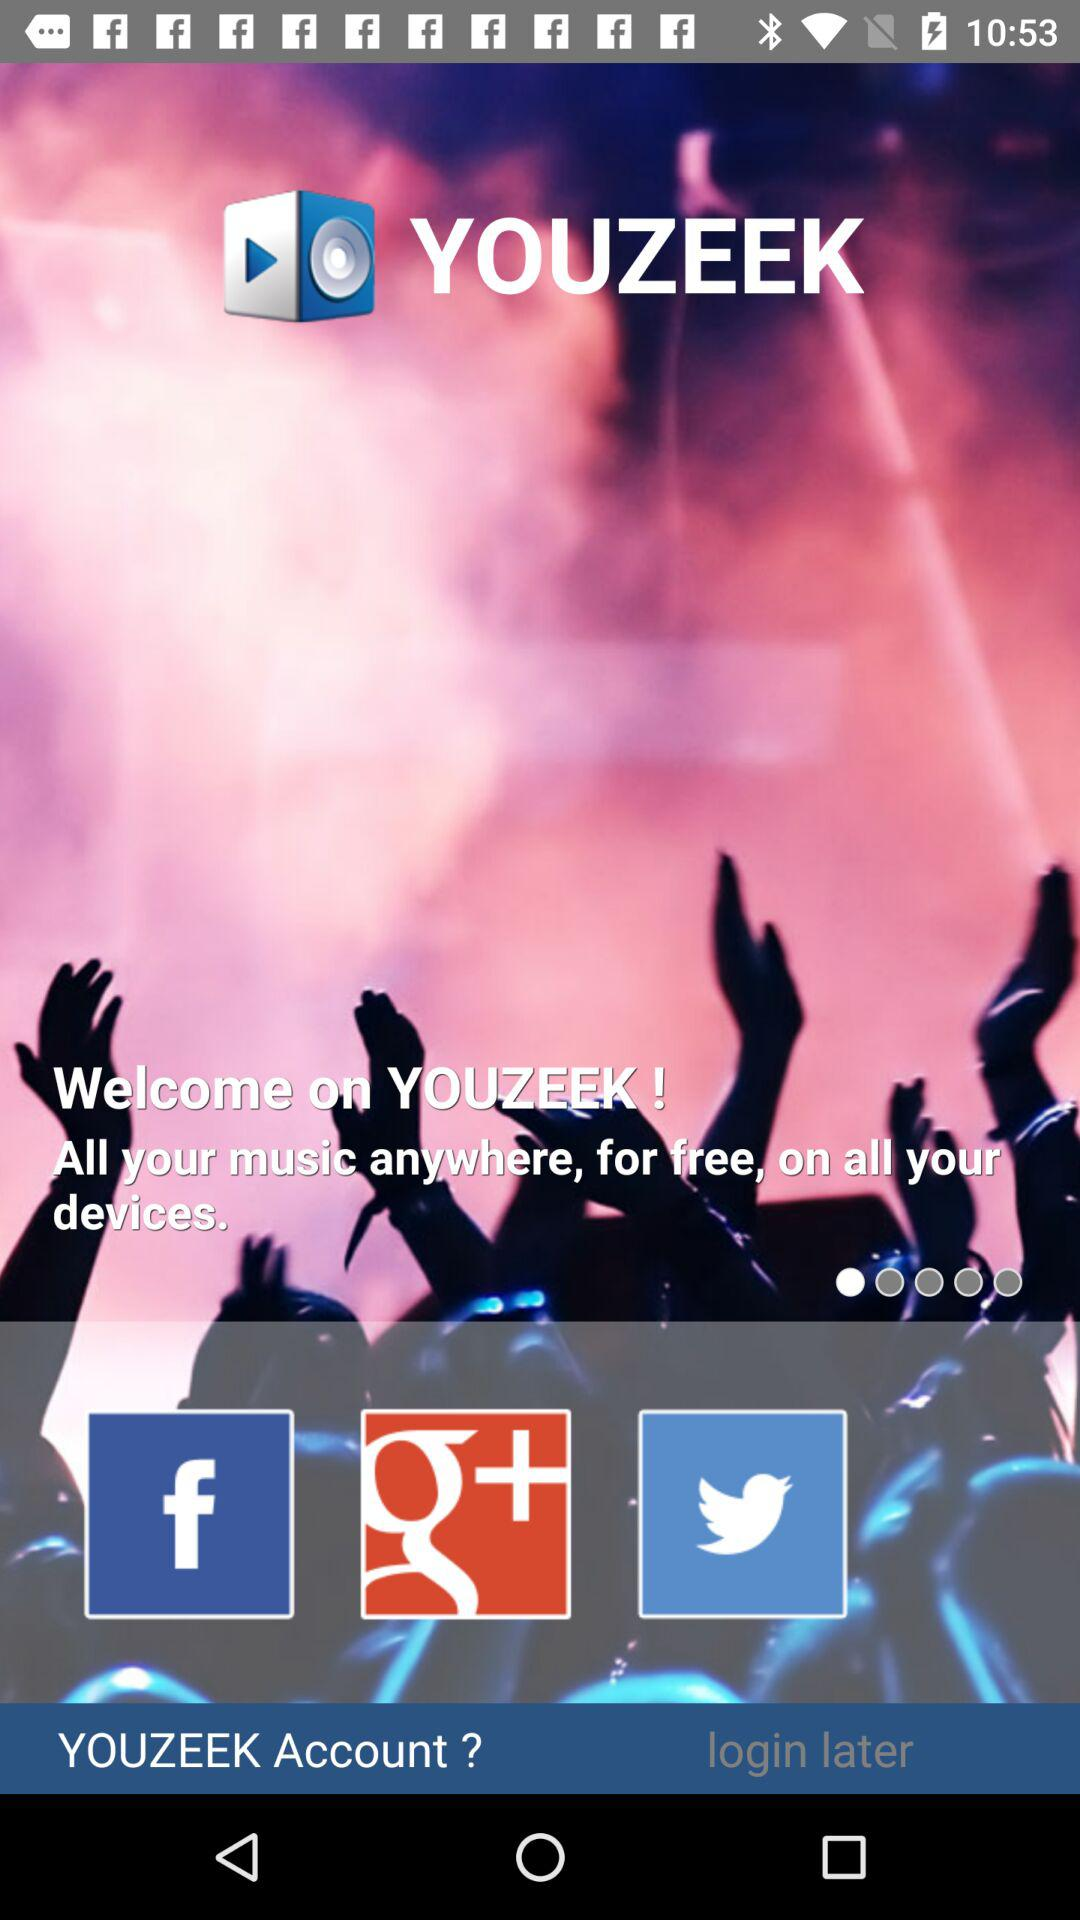What is the name of the application? The name of the application is "YOUZEEK". 